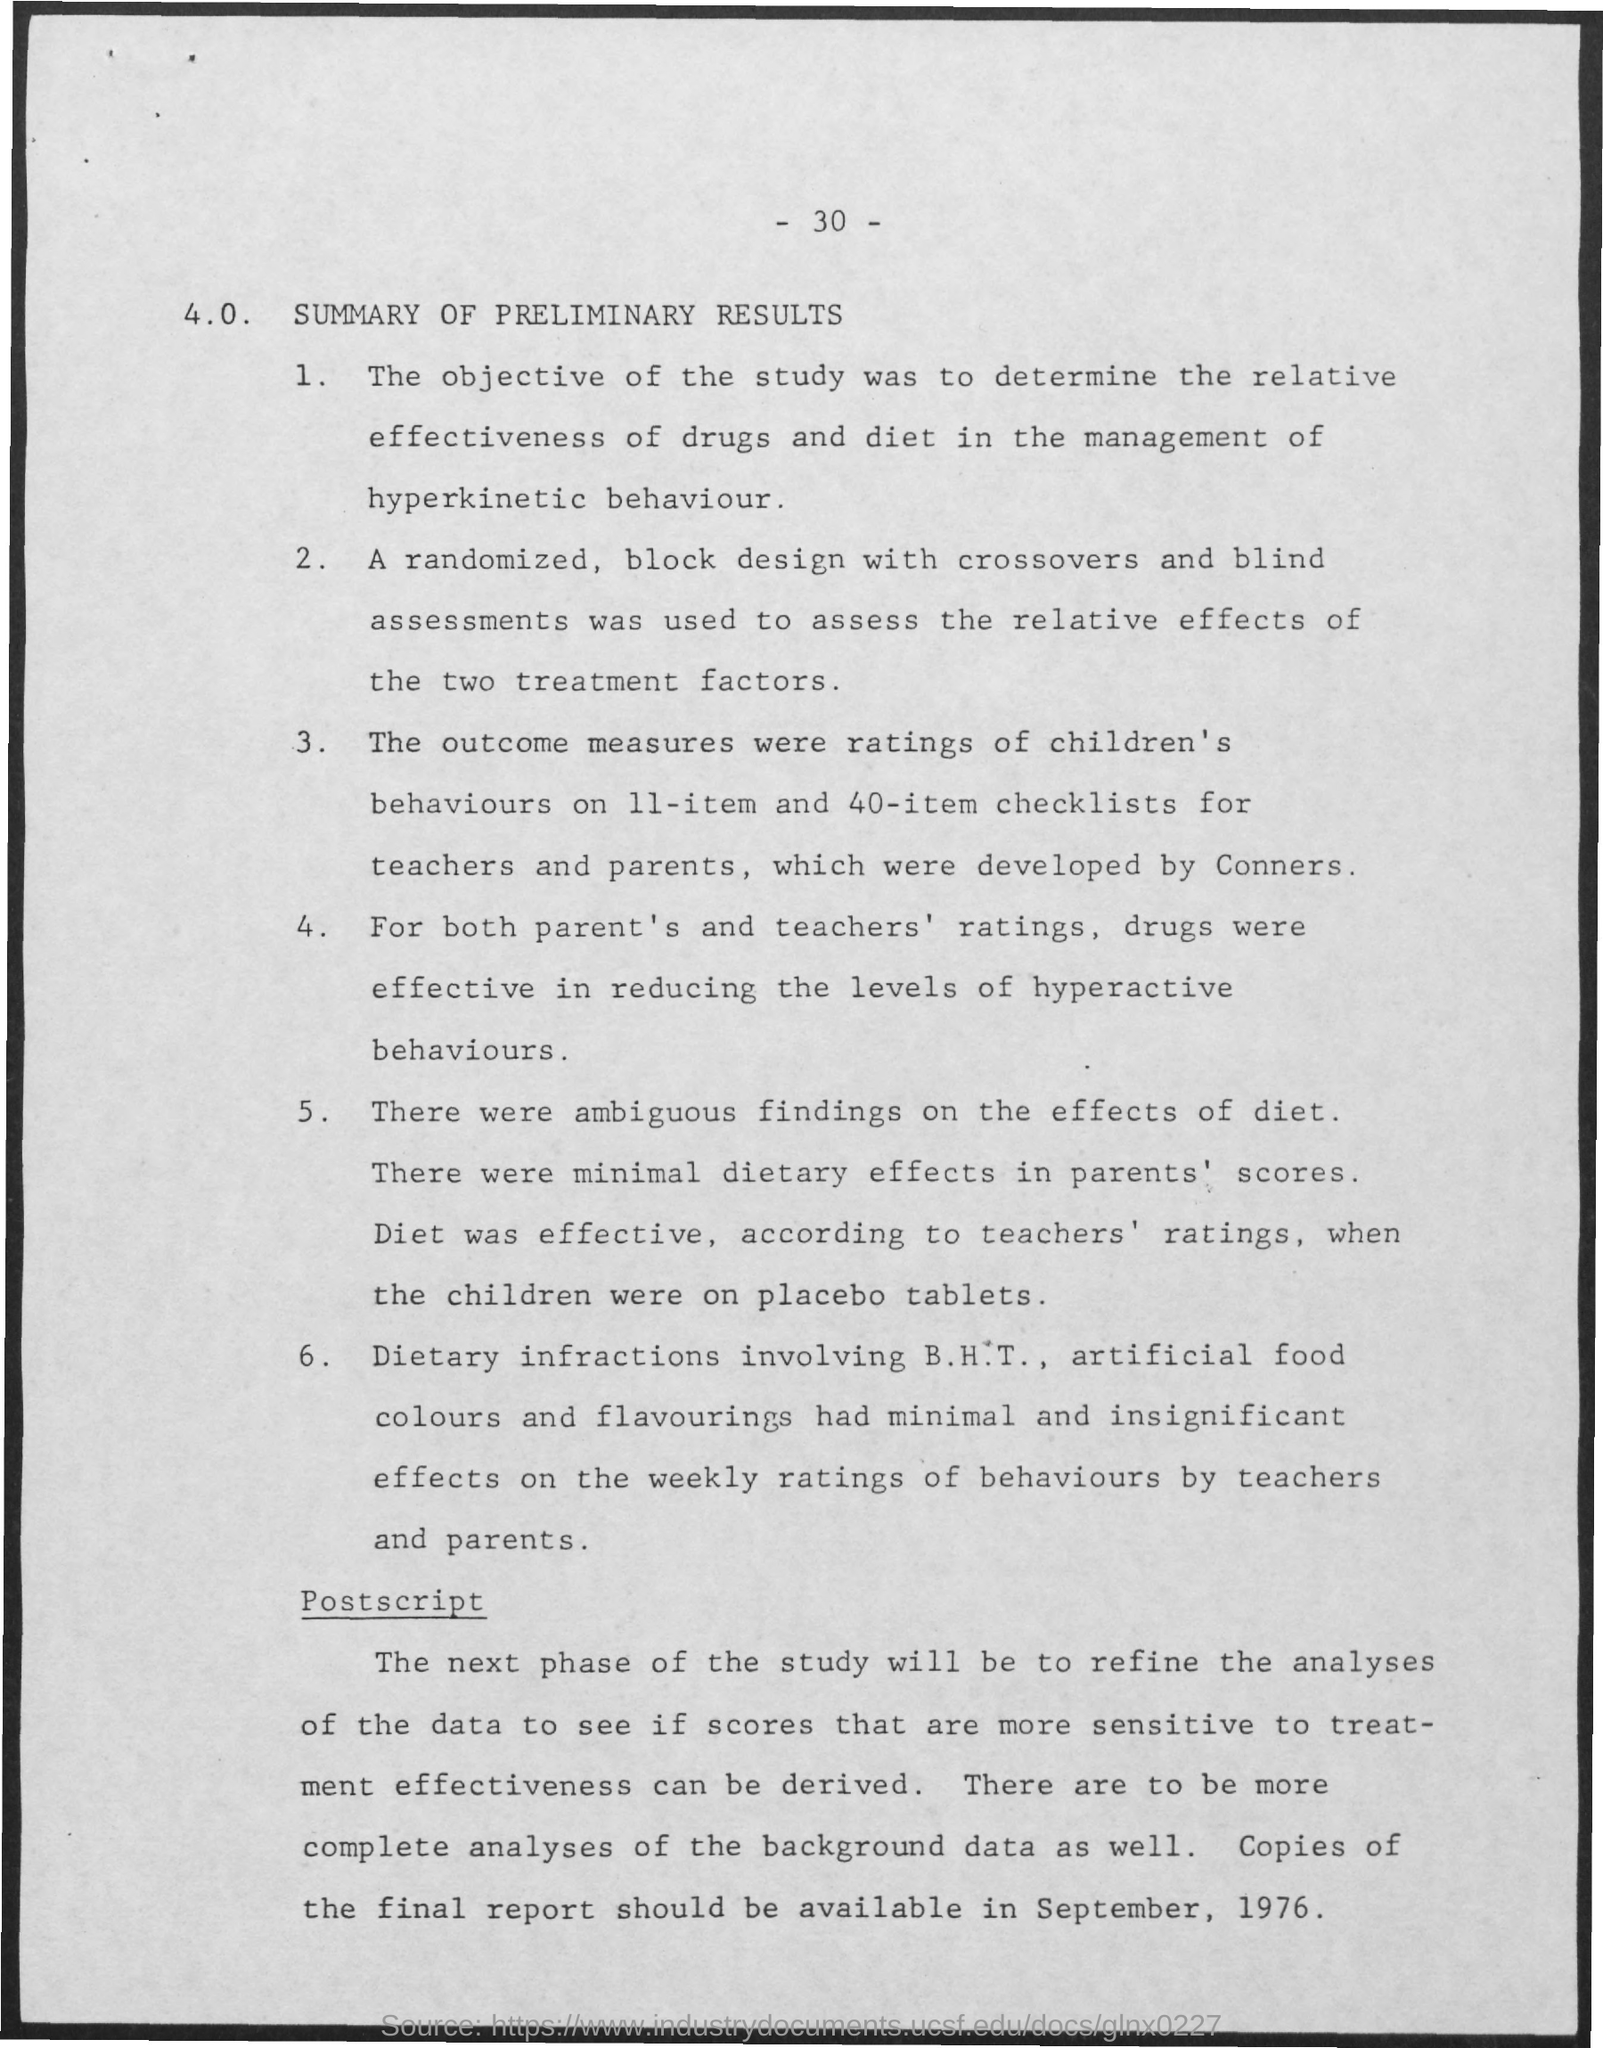Specify some key components in this picture. What is the Page Number?" is a question that concludes "30" and a period. The aim of the research was to evaluate the relative efficacy of medication and dietary interventions in managing hyperkinetic behavior. 